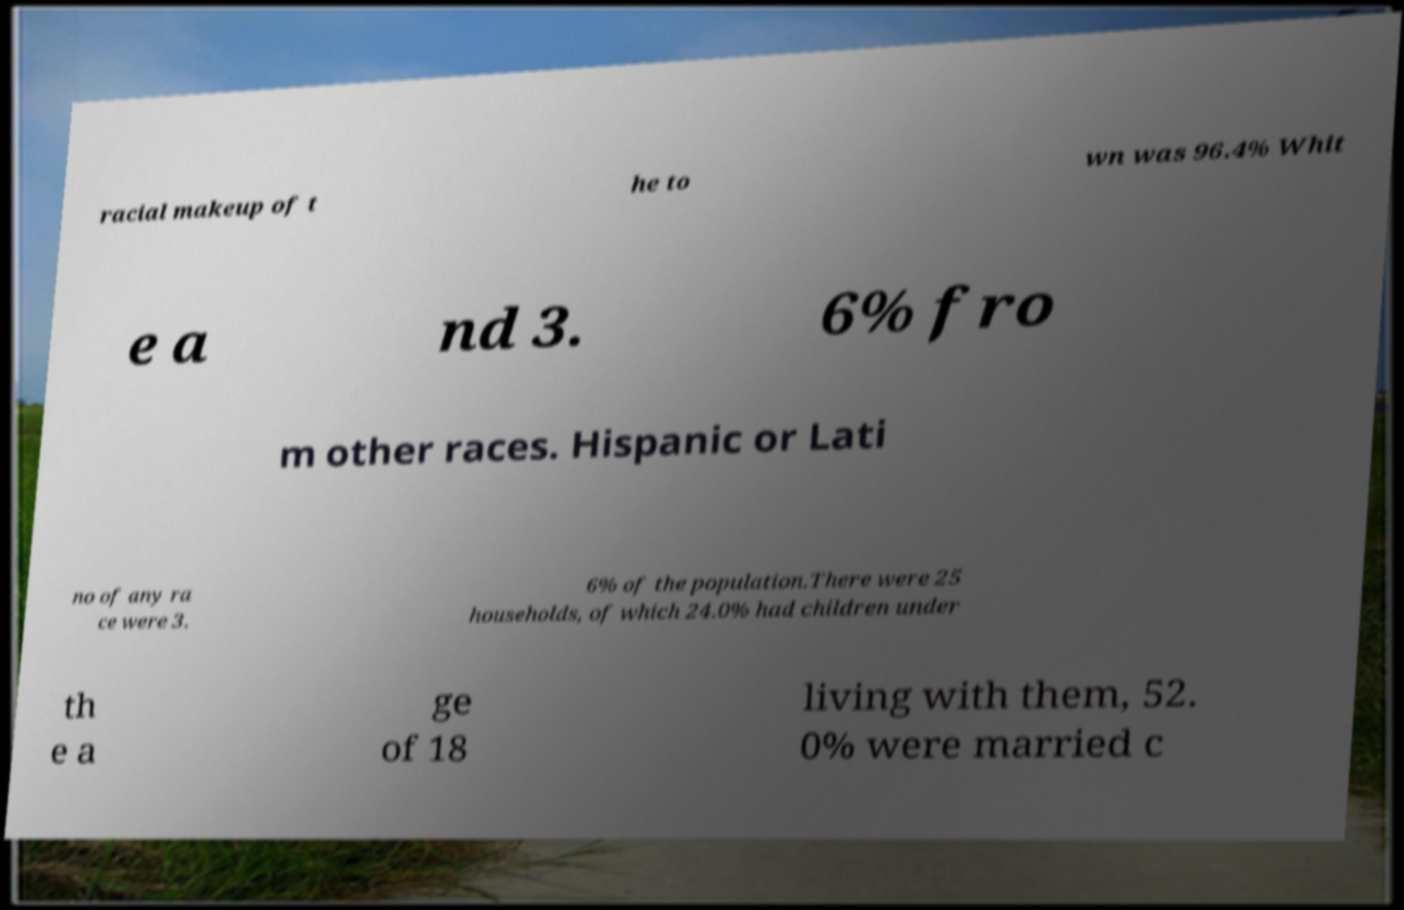Can you read and provide the text displayed in the image?This photo seems to have some interesting text. Can you extract and type it out for me? racial makeup of t he to wn was 96.4% Whit e a nd 3. 6% fro m other races. Hispanic or Lati no of any ra ce were 3. 6% of the population.There were 25 households, of which 24.0% had children under th e a ge of 18 living with them, 52. 0% were married c 